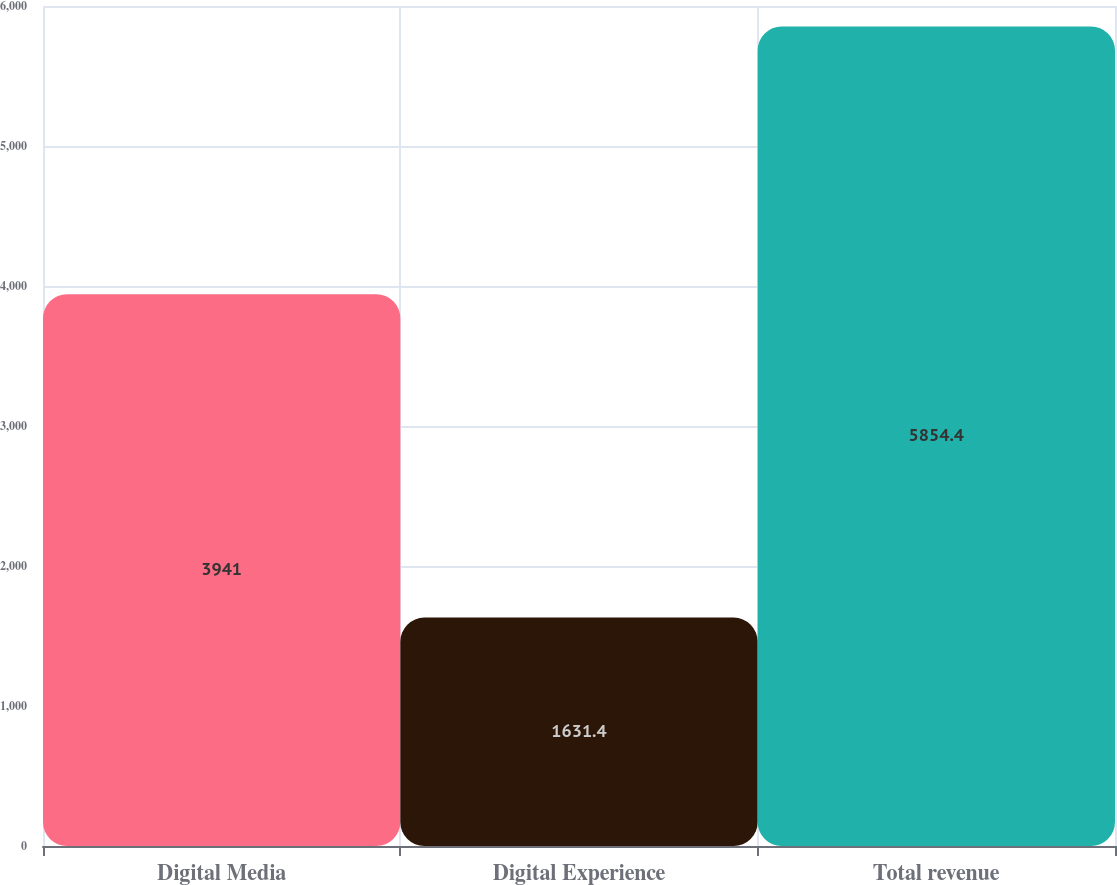Convert chart. <chart><loc_0><loc_0><loc_500><loc_500><bar_chart><fcel>Digital Media<fcel>Digital Experience<fcel>Total revenue<nl><fcel>3941<fcel>1631.4<fcel>5854.4<nl></chart> 